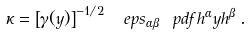<formula> <loc_0><loc_0><loc_500><loc_500>\kappa = \left [ \gamma ( y ) \right ] ^ { - 1 / 2 } \, \ e p s _ { \alpha \beta } \ p d f { h ^ { \alpha } } { y } h ^ { \beta } \, .</formula> 